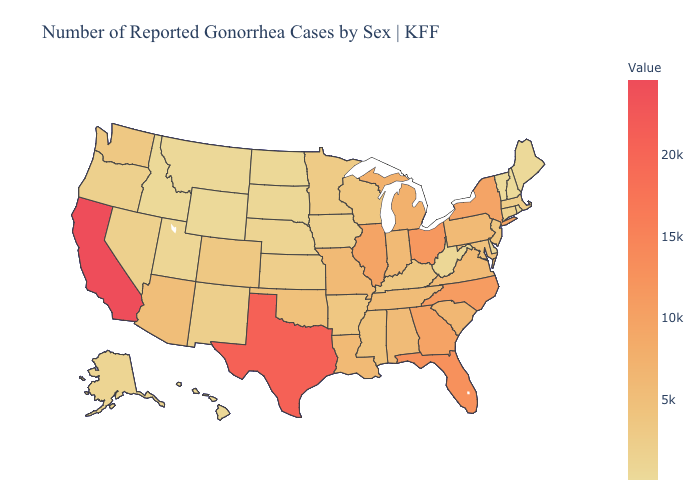Which states have the lowest value in the USA?
Concise answer only. Vermont. Among the states that border West Virginia , which have the highest value?
Answer briefly. Ohio. Does Nevada have a lower value than South Carolina?
Answer briefly. Yes. Does the map have missing data?
Keep it brief. No. Among the states that border Iowa , which have the highest value?
Give a very brief answer. Illinois. Does Vermont have the lowest value in the USA?
Quick response, please. Yes. Which states hav the highest value in the South?
Write a very short answer. Texas. 